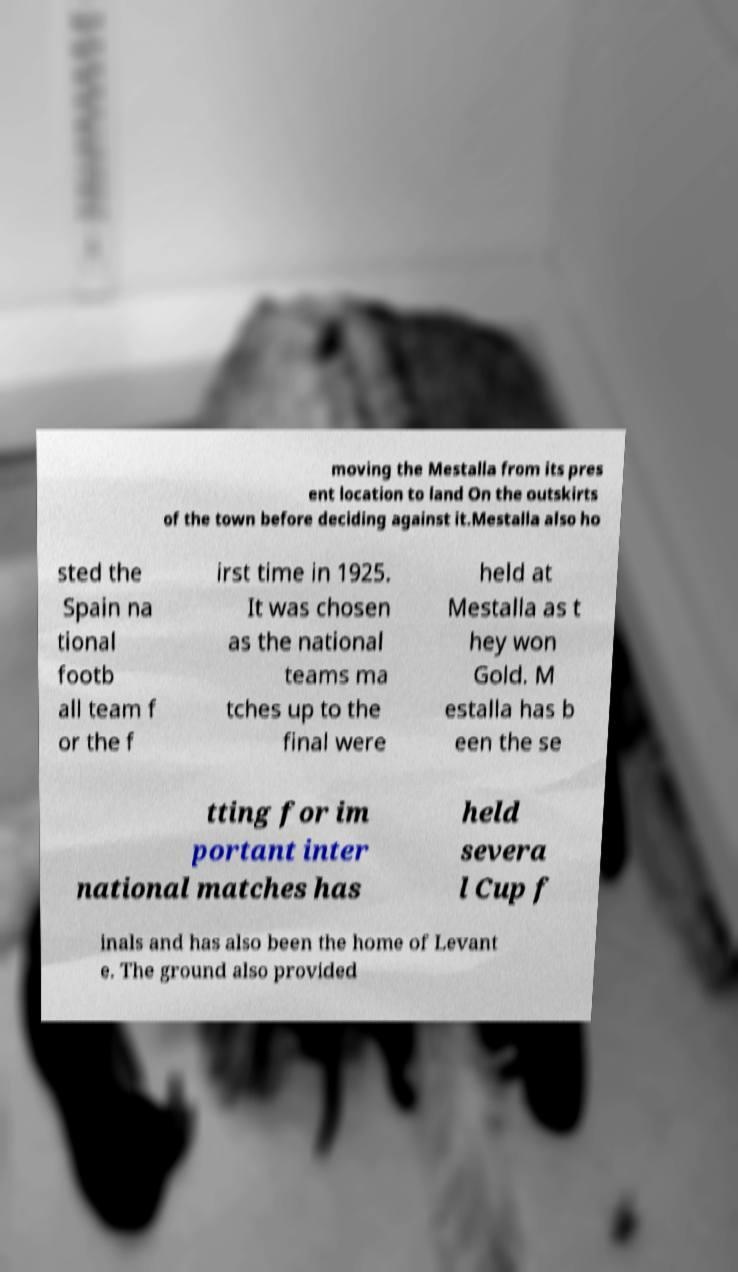Please read and relay the text visible in this image. What does it say? moving the Mestalla from its pres ent location to land On the outskirts of the town before deciding against it.Mestalla also ho sted the Spain na tional footb all team f or the f irst time in 1925. It was chosen as the national teams ma tches up to the final were held at Mestalla as t hey won Gold. M estalla has b een the se tting for im portant inter national matches has held severa l Cup f inals and has also been the home of Levant e. The ground also provided 